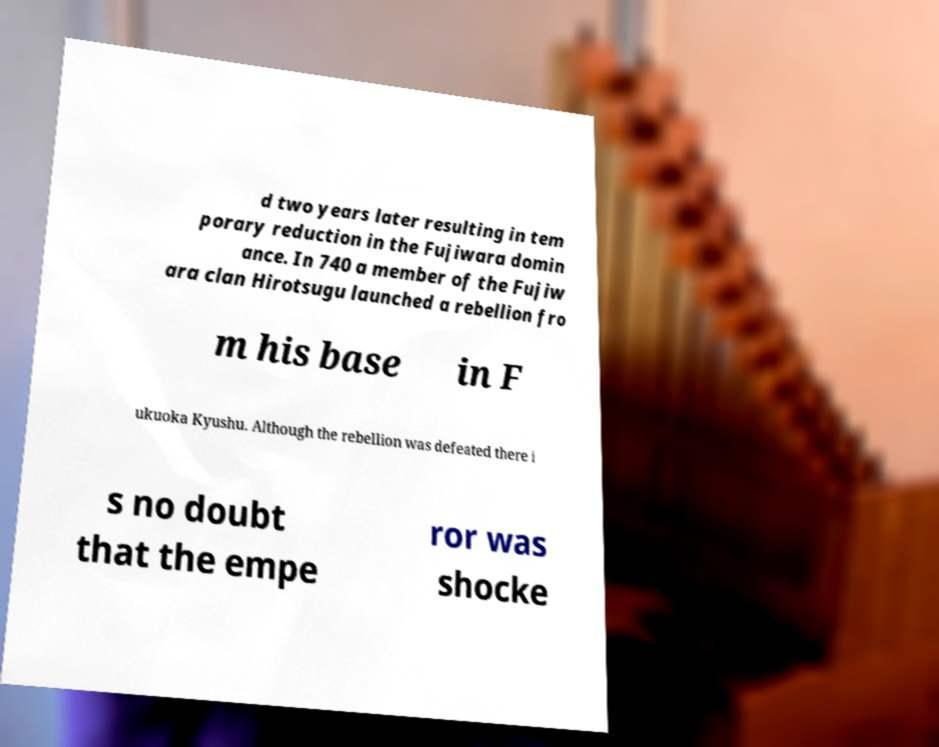Could you assist in decoding the text presented in this image and type it out clearly? d two years later resulting in tem porary reduction in the Fujiwara domin ance. In 740 a member of the Fujiw ara clan Hirotsugu launched a rebellion fro m his base in F ukuoka Kyushu. Although the rebellion was defeated there i s no doubt that the empe ror was shocke 